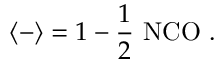Convert formula to latex. <formula><loc_0><loc_0><loc_500><loc_500>\langle - \rangle = 1 - \frac { 1 } { 2 } N C O .</formula> 